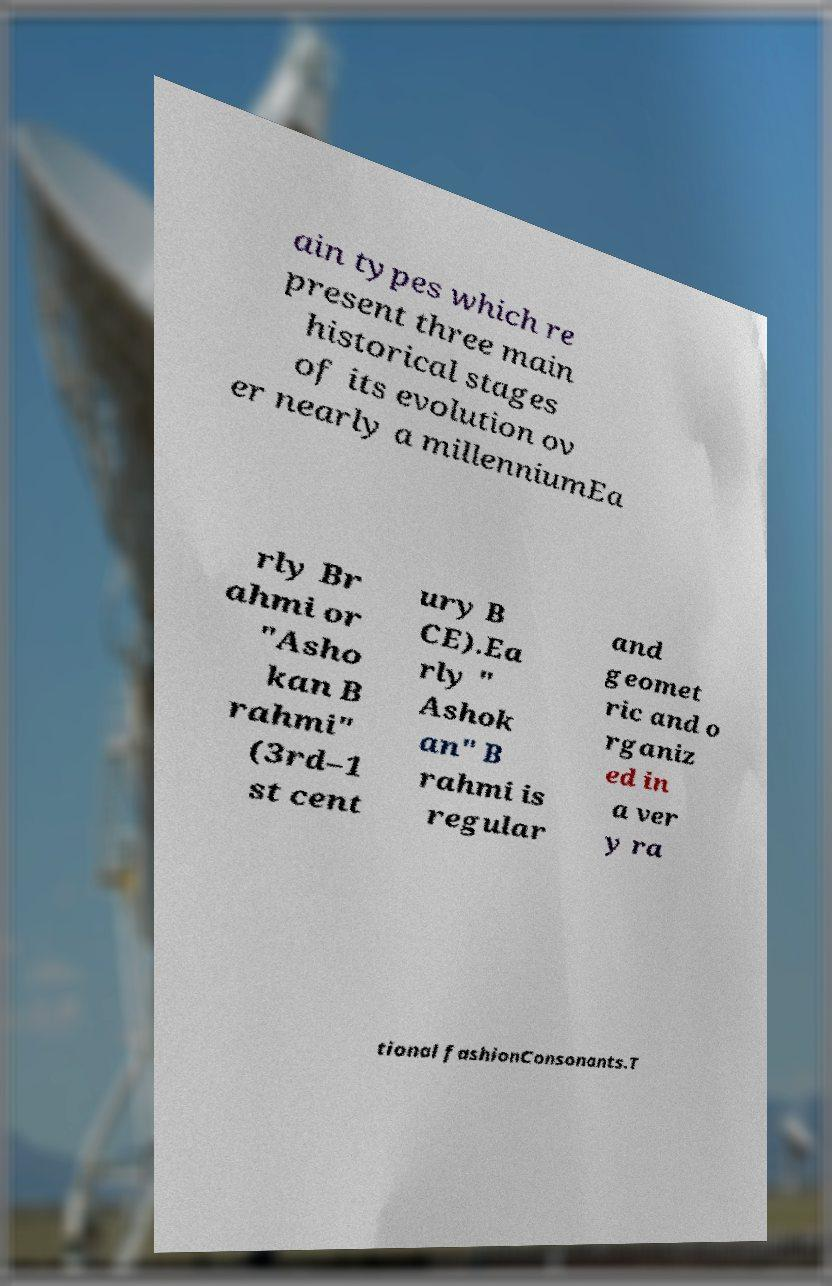I need the written content from this picture converted into text. Can you do that? ain types which re present three main historical stages of its evolution ov er nearly a millenniumEa rly Br ahmi or "Asho kan B rahmi" (3rd–1 st cent ury B CE).Ea rly " Ashok an" B rahmi is regular and geomet ric and o rganiz ed in a ver y ra tional fashionConsonants.T 